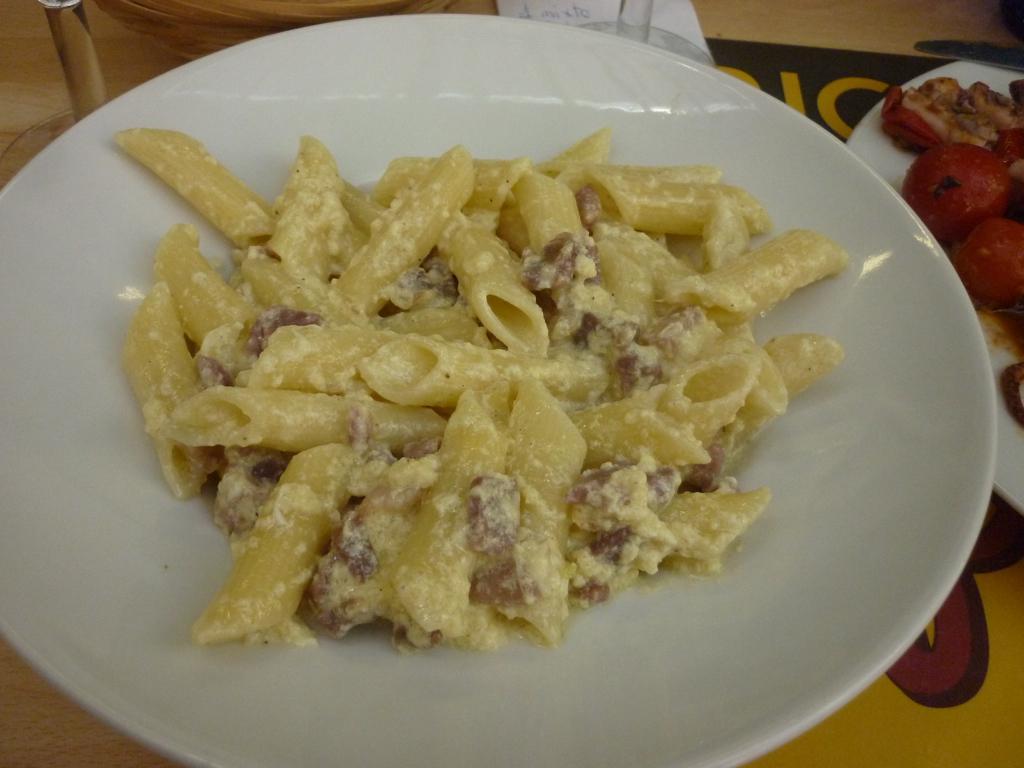Describe this image in one or two sentences. In this image there is a plate in which there is pasta. On the right side top there is another plate in which there is some food stuff. 